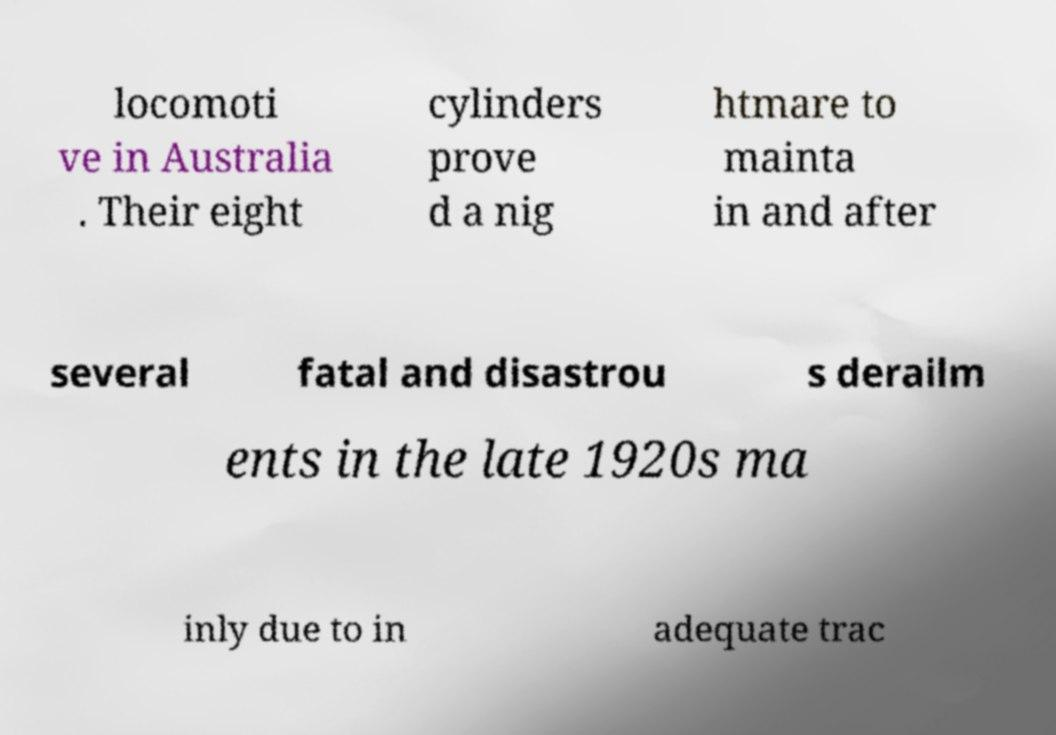Please read and relay the text visible in this image. What does it say? locomoti ve in Australia . Their eight cylinders prove d a nig htmare to mainta in and after several fatal and disastrou s derailm ents in the late 1920s ma inly due to in adequate trac 